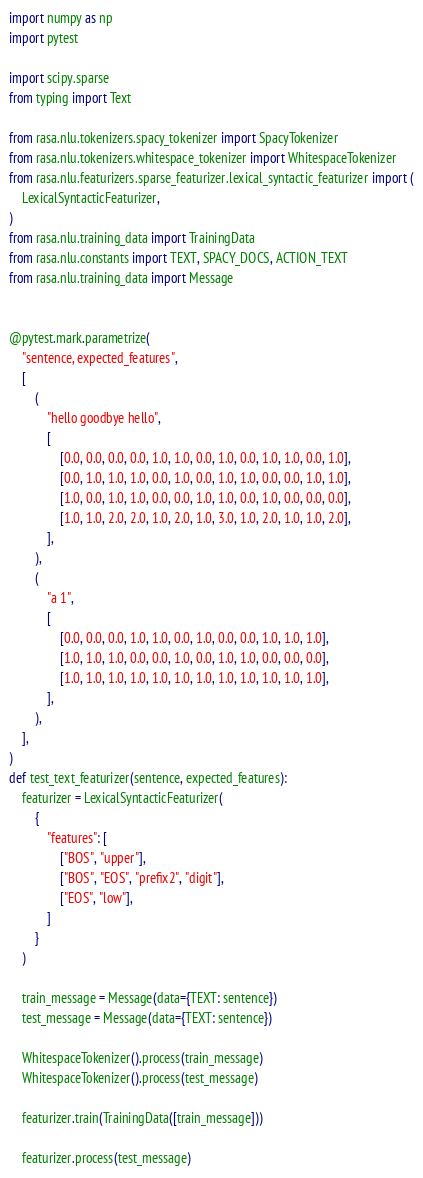Convert code to text. <code><loc_0><loc_0><loc_500><loc_500><_Python_>import numpy as np
import pytest

import scipy.sparse
from typing import Text

from rasa.nlu.tokenizers.spacy_tokenizer import SpacyTokenizer
from rasa.nlu.tokenizers.whitespace_tokenizer import WhitespaceTokenizer
from rasa.nlu.featurizers.sparse_featurizer.lexical_syntactic_featurizer import (
    LexicalSyntacticFeaturizer,
)
from rasa.nlu.training_data import TrainingData
from rasa.nlu.constants import TEXT, SPACY_DOCS, ACTION_TEXT
from rasa.nlu.training_data import Message


@pytest.mark.parametrize(
    "sentence, expected_features",
    [
        (
            "hello goodbye hello",
            [
                [0.0, 0.0, 0.0, 0.0, 1.0, 1.0, 0.0, 1.0, 0.0, 1.0, 1.0, 0.0, 1.0],
                [0.0, 1.0, 1.0, 1.0, 0.0, 1.0, 0.0, 1.0, 1.0, 0.0, 0.0, 1.0, 1.0],
                [1.0, 0.0, 1.0, 1.0, 0.0, 0.0, 1.0, 1.0, 0.0, 1.0, 0.0, 0.0, 0.0],
                [1.0, 1.0, 2.0, 2.0, 1.0, 2.0, 1.0, 3.0, 1.0, 2.0, 1.0, 1.0, 2.0],
            ],
        ),
        (
            "a 1",
            [
                [0.0, 0.0, 0.0, 1.0, 1.0, 0.0, 1.0, 0.0, 0.0, 1.0, 1.0, 1.0],
                [1.0, 1.0, 1.0, 0.0, 0.0, 1.0, 0.0, 1.0, 1.0, 0.0, 0.0, 0.0],
                [1.0, 1.0, 1.0, 1.0, 1.0, 1.0, 1.0, 1.0, 1.0, 1.0, 1.0, 1.0],
            ],
        ),
    ],
)
def test_text_featurizer(sentence, expected_features):
    featurizer = LexicalSyntacticFeaturizer(
        {
            "features": [
                ["BOS", "upper"],
                ["BOS", "EOS", "prefix2", "digit"],
                ["EOS", "low"],
            ]
        }
    )

    train_message = Message(data={TEXT: sentence})
    test_message = Message(data={TEXT: sentence})

    WhitespaceTokenizer().process(train_message)
    WhitespaceTokenizer().process(test_message)

    featurizer.train(TrainingData([train_message]))

    featurizer.process(test_message)
</code> 